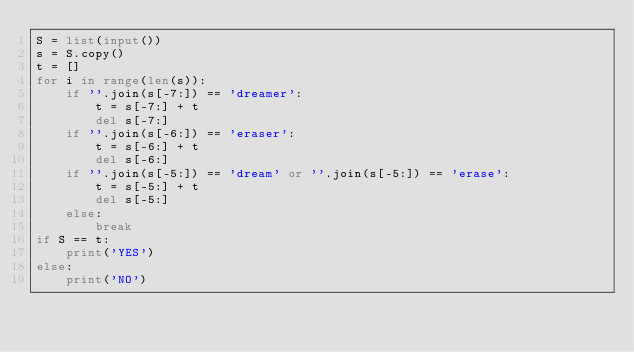<code> <loc_0><loc_0><loc_500><loc_500><_Python_>S = list(input())
s = S.copy()
t = []
for i in range(len(s)):
    if ''.join(s[-7:]) == 'dreamer':
        t = s[-7:] + t
        del s[-7:]
    if ''.join(s[-6:]) == 'eraser':
        t = s[-6:] + t
        del s[-6:]
    if ''.join(s[-5:]) == 'dream' or ''.join(s[-5:]) == 'erase':
        t = s[-5:] + t
        del s[-5:]
    else:
        break
if S == t:
    print('YES')
else:
    print('NO')</code> 